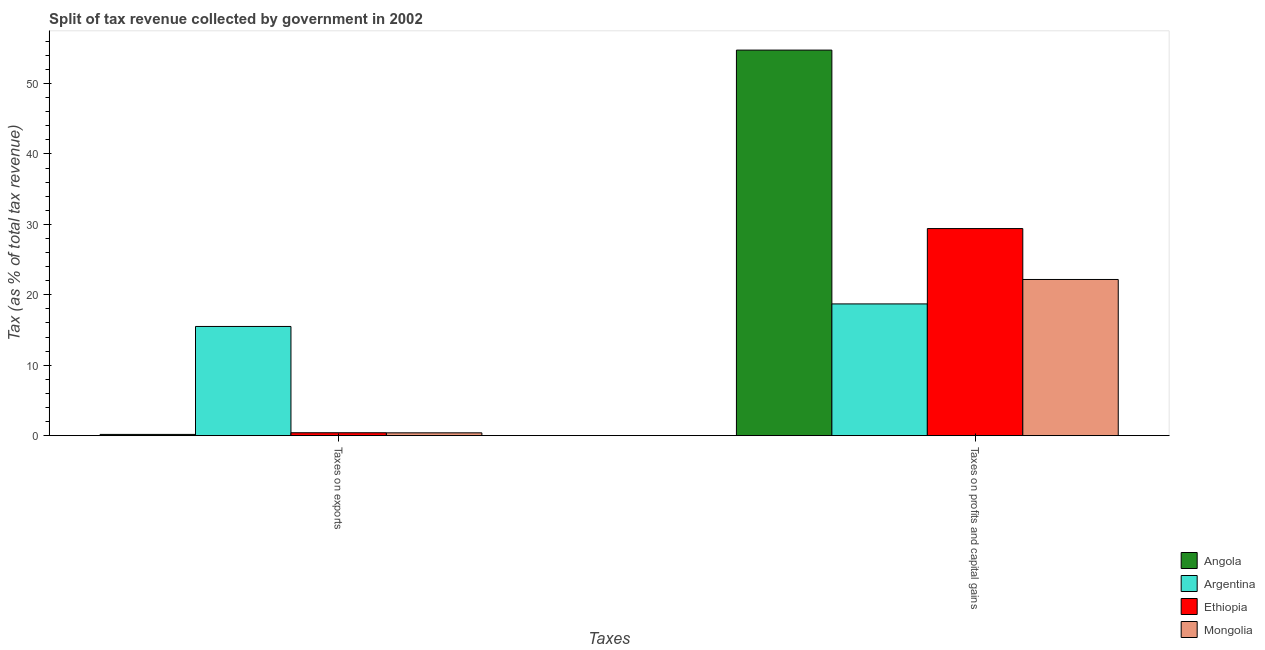Are the number of bars on each tick of the X-axis equal?
Offer a very short reply. Yes. How many bars are there on the 2nd tick from the left?
Your response must be concise. 4. How many bars are there on the 1st tick from the right?
Offer a terse response. 4. What is the label of the 2nd group of bars from the left?
Keep it short and to the point. Taxes on profits and capital gains. What is the percentage of revenue obtained from taxes on profits and capital gains in Angola?
Offer a very short reply. 54.74. Across all countries, what is the maximum percentage of revenue obtained from taxes on profits and capital gains?
Offer a very short reply. 54.74. Across all countries, what is the minimum percentage of revenue obtained from taxes on exports?
Make the answer very short. 0.18. In which country was the percentage of revenue obtained from taxes on profits and capital gains maximum?
Make the answer very short. Angola. In which country was the percentage of revenue obtained from taxes on exports minimum?
Provide a succinct answer. Angola. What is the total percentage of revenue obtained from taxes on exports in the graph?
Make the answer very short. 16.49. What is the difference between the percentage of revenue obtained from taxes on exports in Mongolia and that in Angola?
Give a very brief answer. 0.22. What is the difference between the percentage of revenue obtained from taxes on profits and capital gains in Argentina and the percentage of revenue obtained from taxes on exports in Ethiopia?
Give a very brief answer. 18.29. What is the average percentage of revenue obtained from taxes on exports per country?
Give a very brief answer. 4.12. What is the difference between the percentage of revenue obtained from taxes on exports and percentage of revenue obtained from taxes on profits and capital gains in Ethiopia?
Provide a succinct answer. -28.99. In how many countries, is the percentage of revenue obtained from taxes on profits and capital gains greater than 20 %?
Give a very brief answer. 3. What is the ratio of the percentage of revenue obtained from taxes on exports in Argentina to that in Ethiopia?
Your answer should be very brief. 37.67. Is the percentage of revenue obtained from taxes on exports in Ethiopia less than that in Mongolia?
Offer a terse response. No. In how many countries, is the percentage of revenue obtained from taxes on profits and capital gains greater than the average percentage of revenue obtained from taxes on profits and capital gains taken over all countries?
Your response must be concise. 1. What does the 3rd bar from the left in Taxes on profits and capital gains represents?
Provide a succinct answer. Ethiopia. What does the 2nd bar from the right in Taxes on exports represents?
Offer a very short reply. Ethiopia. How many bars are there?
Make the answer very short. 8. How many countries are there in the graph?
Keep it short and to the point. 4. What is the difference between two consecutive major ticks on the Y-axis?
Offer a very short reply. 10. Are the values on the major ticks of Y-axis written in scientific E-notation?
Ensure brevity in your answer.  No. Does the graph contain any zero values?
Ensure brevity in your answer.  No. Where does the legend appear in the graph?
Offer a terse response. Bottom right. How many legend labels are there?
Keep it short and to the point. 4. What is the title of the graph?
Offer a very short reply. Split of tax revenue collected by government in 2002. Does "Lao PDR" appear as one of the legend labels in the graph?
Provide a short and direct response. No. What is the label or title of the X-axis?
Keep it short and to the point. Taxes. What is the label or title of the Y-axis?
Keep it short and to the point. Tax (as % of total tax revenue). What is the Tax (as % of total tax revenue) of Angola in Taxes on exports?
Ensure brevity in your answer.  0.18. What is the Tax (as % of total tax revenue) of Argentina in Taxes on exports?
Offer a very short reply. 15.5. What is the Tax (as % of total tax revenue) in Ethiopia in Taxes on exports?
Your answer should be compact. 0.41. What is the Tax (as % of total tax revenue) in Mongolia in Taxes on exports?
Offer a very short reply. 0.4. What is the Tax (as % of total tax revenue) in Angola in Taxes on profits and capital gains?
Offer a very short reply. 54.74. What is the Tax (as % of total tax revenue) of Argentina in Taxes on profits and capital gains?
Make the answer very short. 18.7. What is the Tax (as % of total tax revenue) of Ethiopia in Taxes on profits and capital gains?
Keep it short and to the point. 29.4. What is the Tax (as % of total tax revenue) in Mongolia in Taxes on profits and capital gains?
Offer a terse response. 22.17. Across all Taxes, what is the maximum Tax (as % of total tax revenue) of Angola?
Ensure brevity in your answer.  54.74. Across all Taxes, what is the maximum Tax (as % of total tax revenue) of Argentina?
Your answer should be compact. 18.7. Across all Taxes, what is the maximum Tax (as % of total tax revenue) in Ethiopia?
Ensure brevity in your answer.  29.4. Across all Taxes, what is the maximum Tax (as % of total tax revenue) of Mongolia?
Make the answer very short. 22.17. Across all Taxes, what is the minimum Tax (as % of total tax revenue) of Angola?
Your response must be concise. 0.18. Across all Taxes, what is the minimum Tax (as % of total tax revenue) in Argentina?
Your answer should be compact. 15.5. Across all Taxes, what is the minimum Tax (as % of total tax revenue) of Ethiopia?
Provide a succinct answer. 0.41. Across all Taxes, what is the minimum Tax (as % of total tax revenue) of Mongolia?
Offer a terse response. 0.4. What is the total Tax (as % of total tax revenue) in Angola in the graph?
Keep it short and to the point. 54.91. What is the total Tax (as % of total tax revenue) in Argentina in the graph?
Provide a succinct answer. 34.21. What is the total Tax (as % of total tax revenue) in Ethiopia in the graph?
Your answer should be compact. 29.81. What is the total Tax (as % of total tax revenue) in Mongolia in the graph?
Ensure brevity in your answer.  22.57. What is the difference between the Tax (as % of total tax revenue) in Angola in Taxes on exports and that in Taxes on profits and capital gains?
Make the answer very short. -54.56. What is the difference between the Tax (as % of total tax revenue) of Argentina in Taxes on exports and that in Taxes on profits and capital gains?
Your response must be concise. -3.2. What is the difference between the Tax (as % of total tax revenue) in Ethiopia in Taxes on exports and that in Taxes on profits and capital gains?
Provide a succinct answer. -28.99. What is the difference between the Tax (as % of total tax revenue) in Mongolia in Taxes on exports and that in Taxes on profits and capital gains?
Keep it short and to the point. -21.77. What is the difference between the Tax (as % of total tax revenue) in Angola in Taxes on exports and the Tax (as % of total tax revenue) in Argentina in Taxes on profits and capital gains?
Provide a short and direct response. -18.53. What is the difference between the Tax (as % of total tax revenue) of Angola in Taxes on exports and the Tax (as % of total tax revenue) of Ethiopia in Taxes on profits and capital gains?
Your answer should be compact. -29.23. What is the difference between the Tax (as % of total tax revenue) in Angola in Taxes on exports and the Tax (as % of total tax revenue) in Mongolia in Taxes on profits and capital gains?
Your answer should be compact. -22. What is the difference between the Tax (as % of total tax revenue) in Argentina in Taxes on exports and the Tax (as % of total tax revenue) in Ethiopia in Taxes on profits and capital gains?
Ensure brevity in your answer.  -13.9. What is the difference between the Tax (as % of total tax revenue) in Argentina in Taxes on exports and the Tax (as % of total tax revenue) in Mongolia in Taxes on profits and capital gains?
Your answer should be very brief. -6.67. What is the difference between the Tax (as % of total tax revenue) in Ethiopia in Taxes on exports and the Tax (as % of total tax revenue) in Mongolia in Taxes on profits and capital gains?
Keep it short and to the point. -21.76. What is the average Tax (as % of total tax revenue) of Angola per Taxes?
Ensure brevity in your answer.  27.46. What is the average Tax (as % of total tax revenue) in Argentina per Taxes?
Keep it short and to the point. 17.1. What is the average Tax (as % of total tax revenue) in Ethiopia per Taxes?
Your answer should be compact. 14.91. What is the average Tax (as % of total tax revenue) in Mongolia per Taxes?
Offer a terse response. 11.29. What is the difference between the Tax (as % of total tax revenue) in Angola and Tax (as % of total tax revenue) in Argentina in Taxes on exports?
Make the answer very short. -15.33. What is the difference between the Tax (as % of total tax revenue) in Angola and Tax (as % of total tax revenue) in Ethiopia in Taxes on exports?
Your answer should be very brief. -0.24. What is the difference between the Tax (as % of total tax revenue) of Angola and Tax (as % of total tax revenue) of Mongolia in Taxes on exports?
Give a very brief answer. -0.22. What is the difference between the Tax (as % of total tax revenue) in Argentina and Tax (as % of total tax revenue) in Ethiopia in Taxes on exports?
Your response must be concise. 15.09. What is the difference between the Tax (as % of total tax revenue) of Argentina and Tax (as % of total tax revenue) of Mongolia in Taxes on exports?
Give a very brief answer. 15.1. What is the difference between the Tax (as % of total tax revenue) of Ethiopia and Tax (as % of total tax revenue) of Mongolia in Taxes on exports?
Offer a very short reply. 0.01. What is the difference between the Tax (as % of total tax revenue) of Angola and Tax (as % of total tax revenue) of Argentina in Taxes on profits and capital gains?
Offer a terse response. 36.04. What is the difference between the Tax (as % of total tax revenue) of Angola and Tax (as % of total tax revenue) of Ethiopia in Taxes on profits and capital gains?
Offer a terse response. 25.34. What is the difference between the Tax (as % of total tax revenue) in Angola and Tax (as % of total tax revenue) in Mongolia in Taxes on profits and capital gains?
Provide a short and direct response. 32.57. What is the difference between the Tax (as % of total tax revenue) in Argentina and Tax (as % of total tax revenue) in Ethiopia in Taxes on profits and capital gains?
Offer a very short reply. -10.7. What is the difference between the Tax (as % of total tax revenue) in Argentina and Tax (as % of total tax revenue) in Mongolia in Taxes on profits and capital gains?
Offer a terse response. -3.47. What is the difference between the Tax (as % of total tax revenue) of Ethiopia and Tax (as % of total tax revenue) of Mongolia in Taxes on profits and capital gains?
Your answer should be very brief. 7.23. What is the ratio of the Tax (as % of total tax revenue) of Angola in Taxes on exports to that in Taxes on profits and capital gains?
Provide a short and direct response. 0. What is the ratio of the Tax (as % of total tax revenue) in Argentina in Taxes on exports to that in Taxes on profits and capital gains?
Give a very brief answer. 0.83. What is the ratio of the Tax (as % of total tax revenue) in Ethiopia in Taxes on exports to that in Taxes on profits and capital gains?
Offer a terse response. 0.01. What is the ratio of the Tax (as % of total tax revenue) in Mongolia in Taxes on exports to that in Taxes on profits and capital gains?
Give a very brief answer. 0.02. What is the difference between the highest and the second highest Tax (as % of total tax revenue) of Angola?
Provide a succinct answer. 54.56. What is the difference between the highest and the second highest Tax (as % of total tax revenue) of Argentina?
Provide a succinct answer. 3.2. What is the difference between the highest and the second highest Tax (as % of total tax revenue) of Ethiopia?
Keep it short and to the point. 28.99. What is the difference between the highest and the second highest Tax (as % of total tax revenue) in Mongolia?
Make the answer very short. 21.77. What is the difference between the highest and the lowest Tax (as % of total tax revenue) of Angola?
Offer a very short reply. 54.56. What is the difference between the highest and the lowest Tax (as % of total tax revenue) of Argentina?
Give a very brief answer. 3.2. What is the difference between the highest and the lowest Tax (as % of total tax revenue) in Ethiopia?
Provide a succinct answer. 28.99. What is the difference between the highest and the lowest Tax (as % of total tax revenue) in Mongolia?
Your response must be concise. 21.77. 